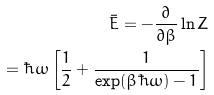<formula> <loc_0><loc_0><loc_500><loc_500>\bar { E } = - \frac { \partial } { \partial \beta } \ln Z \\ = \hbar { \omega } \left [ \frac { 1 } { 2 } + \frac { 1 } { \exp ( \beta \hbar { \omega } ) - 1 } \right ]</formula> 